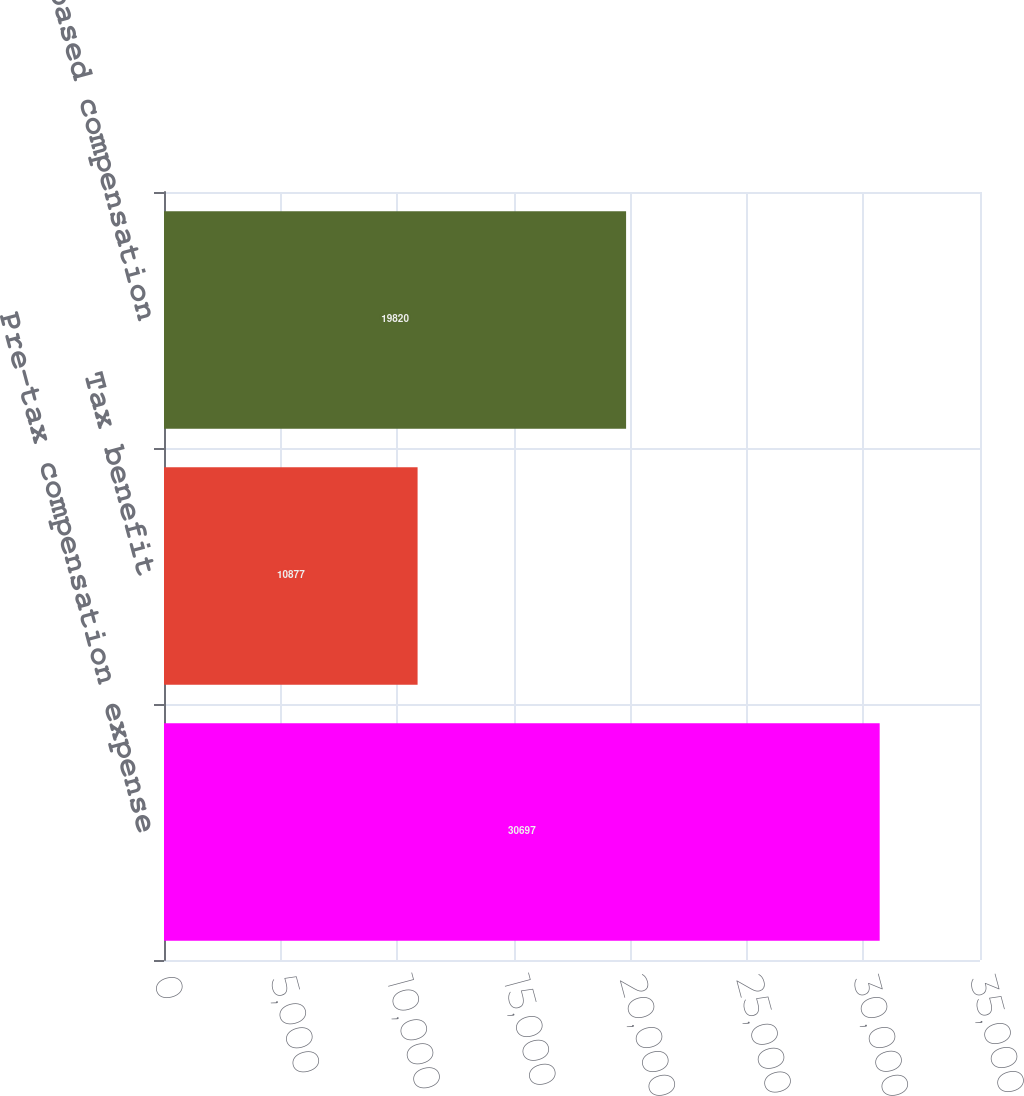<chart> <loc_0><loc_0><loc_500><loc_500><bar_chart><fcel>Pre-tax compensation expense<fcel>Tax benefit<fcel>Total stock-based compensation<nl><fcel>30697<fcel>10877<fcel>19820<nl></chart> 